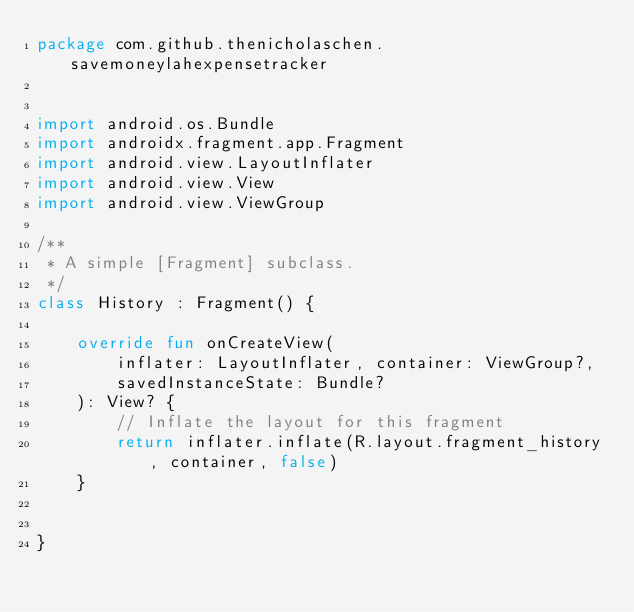<code> <loc_0><loc_0><loc_500><loc_500><_Kotlin_>package com.github.thenicholaschen.savemoneylahexpensetracker


import android.os.Bundle
import androidx.fragment.app.Fragment
import android.view.LayoutInflater
import android.view.View
import android.view.ViewGroup

/**
 * A simple [Fragment] subclass.
 */
class History : Fragment() {

    override fun onCreateView(
        inflater: LayoutInflater, container: ViewGroup?,
        savedInstanceState: Bundle?
    ): View? {
        // Inflate the layout for this fragment
        return inflater.inflate(R.layout.fragment_history, container, false)
    }


}
</code> 